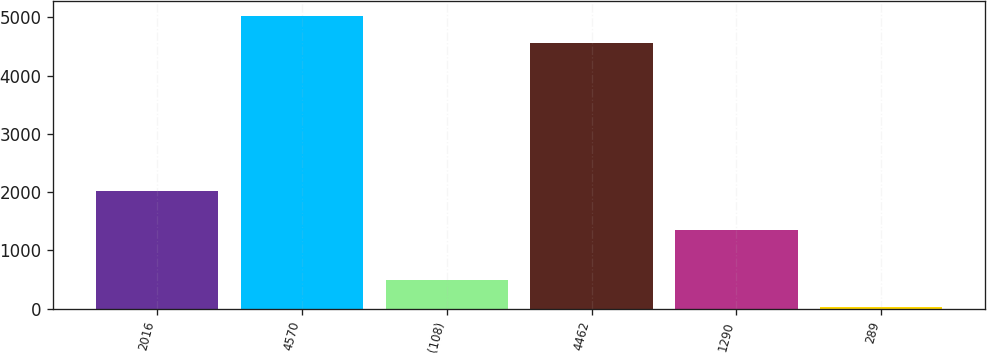Convert chart. <chart><loc_0><loc_0><loc_500><loc_500><bar_chart><fcel>2016<fcel>4570<fcel>(108)<fcel>4462<fcel>1290<fcel>289<nl><fcel>2016<fcel>5030.44<fcel>494.04<fcel>4566<fcel>1352<fcel>29.6<nl></chart> 